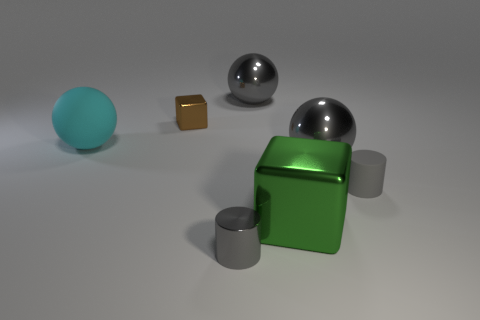The rubber object that is left of the block that is on the left side of the green metallic object is what color?
Keep it short and to the point. Cyan. What number of other objects are the same shape as the brown object?
Offer a very short reply. 1. Is there a brown block made of the same material as the large green block?
Keep it short and to the point. Yes. There is a gray thing that is the same size as the gray metallic cylinder; what is its material?
Give a very brief answer. Rubber. What color is the tiny cylinder in front of the matte object that is on the right side of the big thing on the right side of the big cube?
Your answer should be very brief. Gray. Does the large gray thing that is in front of the cyan sphere have the same shape as the matte thing on the left side of the big green metallic block?
Keep it short and to the point. Yes. How many small cyan metal cylinders are there?
Your answer should be compact. 0. The cylinder that is the same size as the gray rubber object is what color?
Provide a succinct answer. Gray. Does the cylinder that is in front of the small matte cylinder have the same material as the tiny object behind the small gray matte cylinder?
Provide a succinct answer. Yes. What is the size of the metallic sphere behind the sphere that is on the right side of the green shiny cube?
Offer a very short reply. Large. 